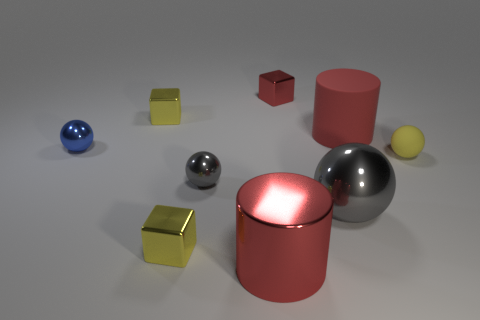Subtract all cyan cubes. How many gray balls are left? 2 Subtract all yellow cubes. How many cubes are left? 1 Add 1 small red metallic things. How many objects exist? 10 Subtract all yellow spheres. How many spheres are left? 3 Subtract 1 blocks. How many blocks are left? 2 Subtract all spheres. How many objects are left? 5 Subtract all blue spheres. Subtract all yellow cylinders. How many spheres are left? 3 Subtract all big metal cylinders. Subtract all large objects. How many objects are left? 5 Add 4 yellow metallic blocks. How many yellow metallic blocks are left? 6 Add 9 large rubber cylinders. How many large rubber cylinders exist? 10 